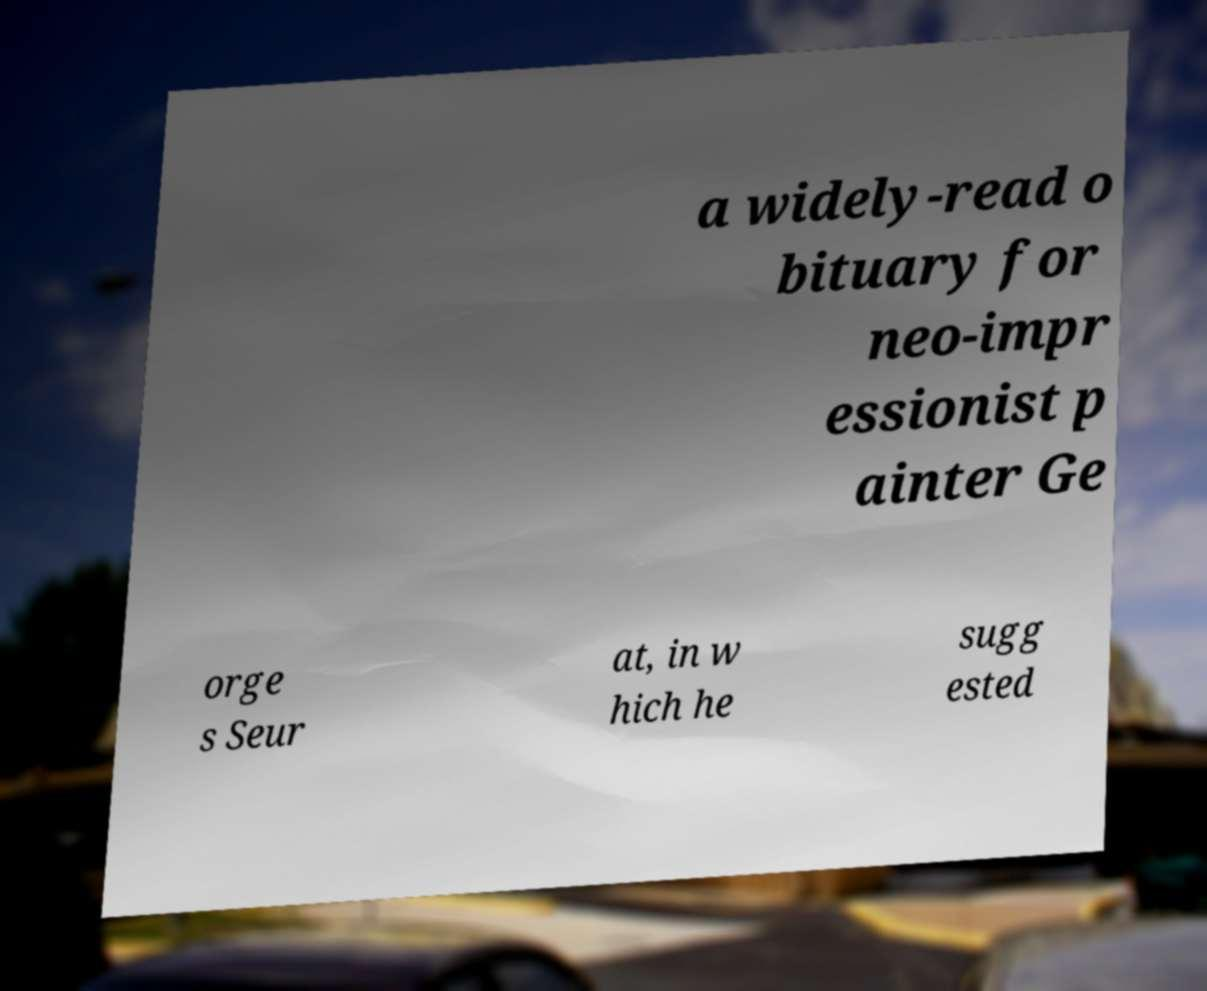What messages or text are displayed in this image? I need them in a readable, typed format. a widely-read o bituary for neo-impr essionist p ainter Ge orge s Seur at, in w hich he sugg ested 